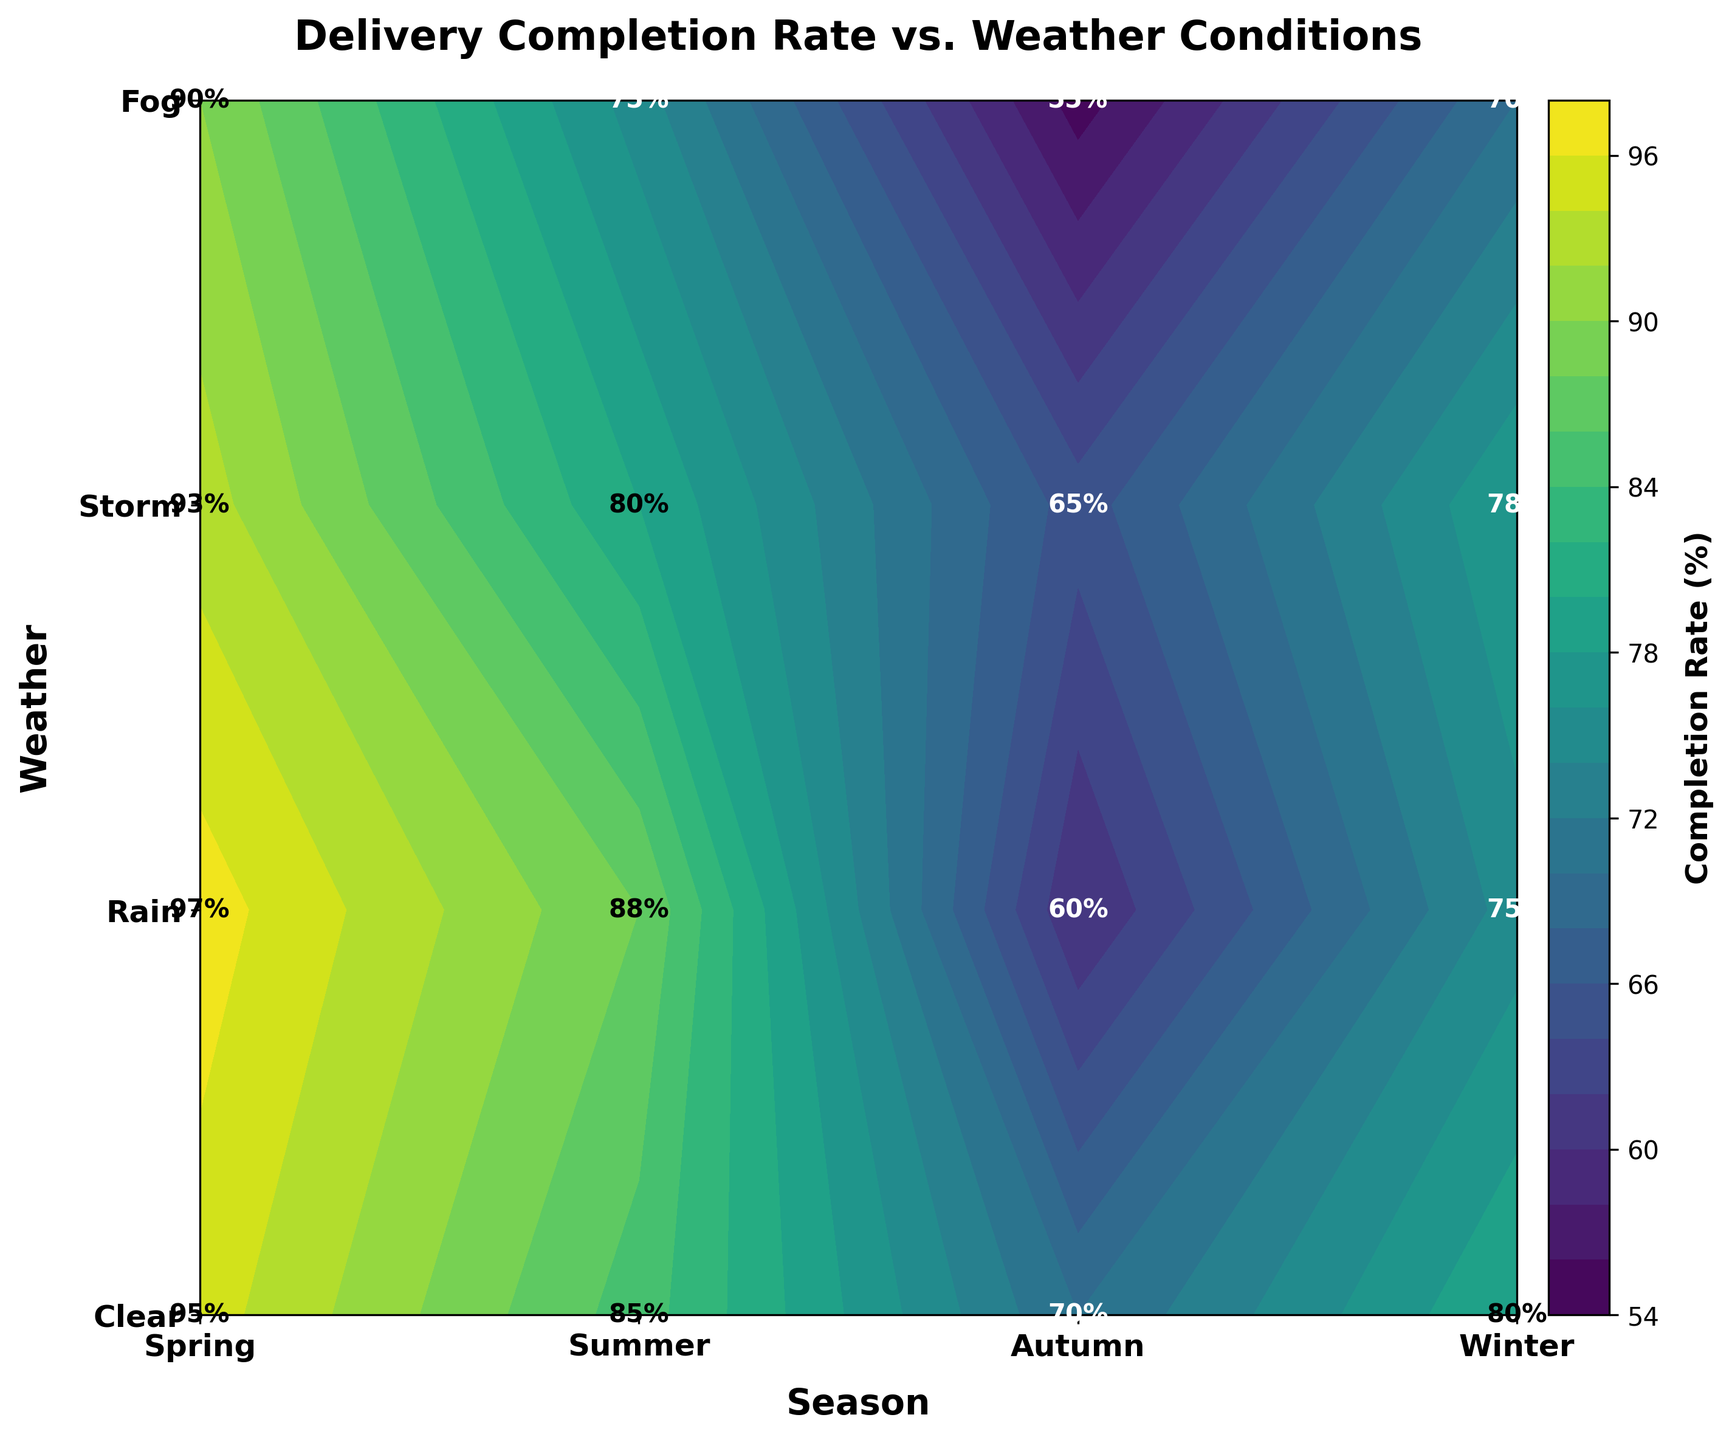What is the title of the plot? The title is located at the top of the plot in larger, bold font.
Answer: Delivery Completion Rate vs. Weather Conditions Which season had the highest delivery completion rate in clear weather? By examining the contour plot, look for the highest number in the "Clear" row. Spring has a rate of 95%, Summer 97%, Autumn 93%, and Winter 90%. The highest is in Summer.
Answer: Summer What is the average delivery completion rate for rainy weather across all seasons? Sum the delivery completion rates for Rainy weather (Spring: 85, Summer: 88, Autumn: 80, Winter: 75) and then divide by 4. (85+88+80+75)/4 = 82
Answer: 82 How does the delivery completion rate in storms compare between Autumn and Winter? Locate the rates for Storm in Autumn and Winter on the contour plot. Autumn has 65% and Winter has 55%. Autumn's rate is higher.
Answer: Autumn's rate is higher Which weather condition shows the biggest drop in delivery completion rate in Winter compared to Spring? Calculate the difference for each weather condition: Clear (95 - 90 = 5), Rain (85 - 75 = 10), Storm (70 - 55 = 15), Fog (80 - 70 = 10), the biggest drop is in Storm.
Answer: Storm What is the overall lowest delivery completion rate and in which conditions was it observed? Identify the lowest number in the contour plot. The lowest value is 55%, found in Winter during Storms.
Answer: 55% in Winter Storms Describe the color gradient observed for completion rates in the plot. The contour plot uses a color gradient from dark to light corresponding to the completion rates. Darker colors indicate lower rates, while lighter colors indicate higher rates.
Answer: Dark to light Which season had a more consistent delivery completion rate across different weather conditions? Compare the variability of the rates across weather conditions for each season. Spring's rates vary from 70 to 95, Summer from 60 to 97, Autumn from 65 to 93, and Winter from 55 to 90. Winter shows the highest variability, while Autumn shows less variability.
Answer: Autumn Is the completion rate during foggy conditions ever above 80%? Check the rates associated with foggy weather. Spring: 80%, Summer: 75%, Autumn: 78%, Winter: 70%. No rate is above 80%.
Answer: No How much higher is the completion rate in clear weather during Spring compared to foggy weather in Winter? Subtract the completion rate of foggy Winter from clear Spring. Clear Spring is 95%, and foggy Winter is 70%, so 95 - 70 = 25.
Answer: 25 